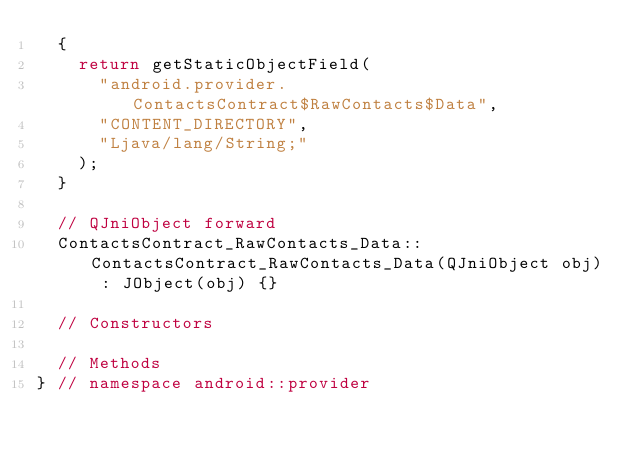<code> <loc_0><loc_0><loc_500><loc_500><_C++_>	{
		return getStaticObjectField(
			"android.provider.ContactsContract$RawContacts$Data",
			"CONTENT_DIRECTORY",
			"Ljava/lang/String;"
		);
	}
	
	// QJniObject forward
	ContactsContract_RawContacts_Data::ContactsContract_RawContacts_Data(QJniObject obj) : JObject(obj) {}
	
	// Constructors
	
	// Methods
} // namespace android::provider

</code> 